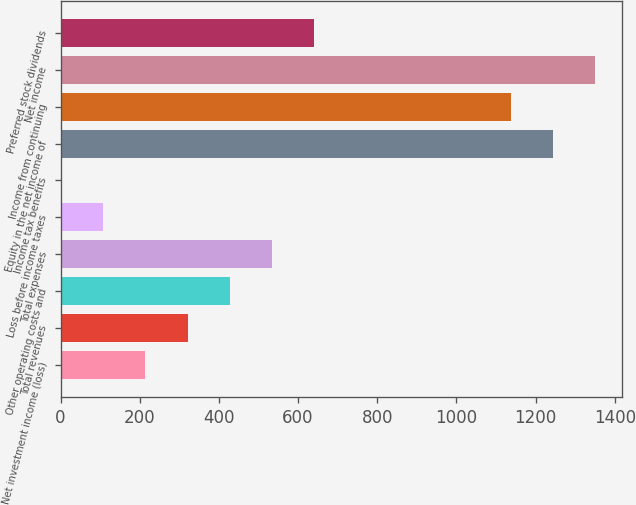<chart> <loc_0><loc_0><loc_500><loc_500><bar_chart><fcel>Net investment income (loss)<fcel>Total revenues<fcel>Other operating costs and<fcel>Total expenses<fcel>Loss before income taxes<fcel>Income tax benefits<fcel>Equity in the net income of<fcel>Income from continuing<fcel>Net income<fcel>Preferred stock dividends<nl><fcel>214.62<fcel>320.83<fcel>427.04<fcel>533.25<fcel>108.41<fcel>2.2<fcel>1243.72<fcel>1137.51<fcel>1349.93<fcel>639.46<nl></chart> 